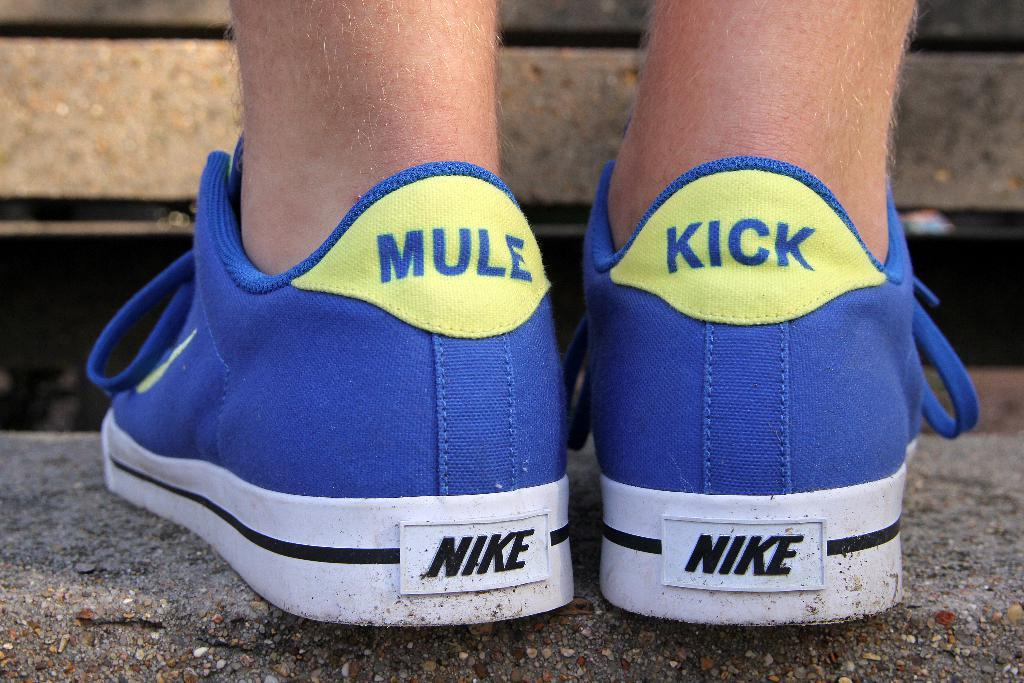<image>
Render a clear and concise summary of the photo. A pair of blue Nike sneakers have been modified to display the word MULE on one and KICK on the other. 